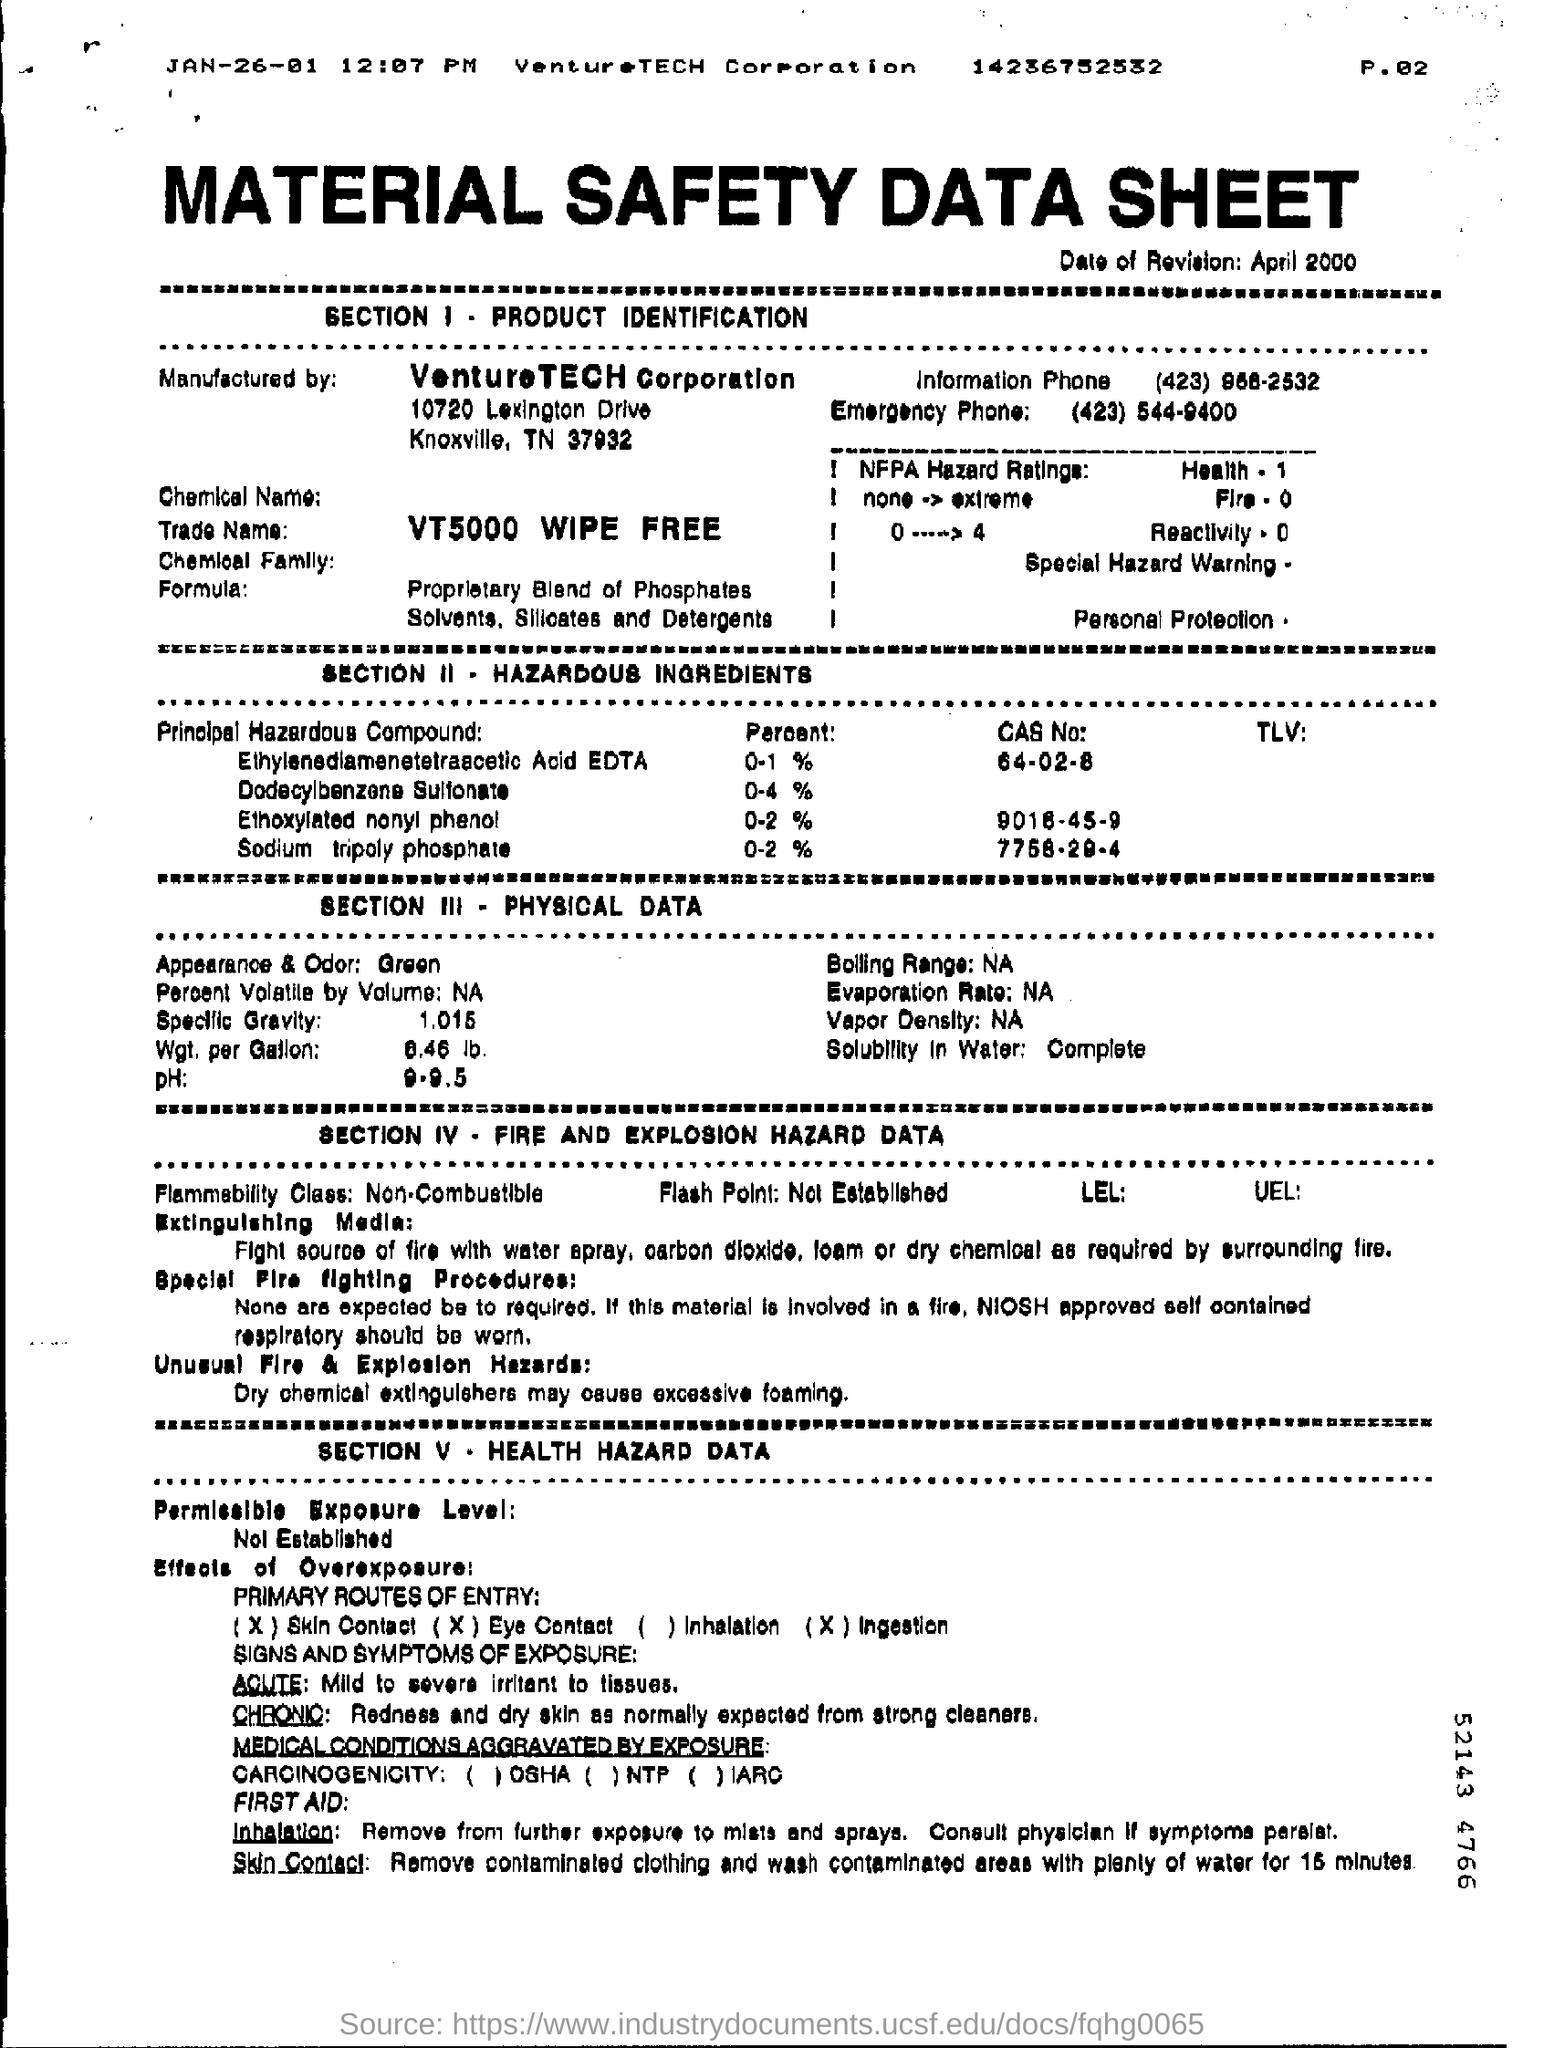What is the Date of Revision?
Give a very brief answer. April 2000. Who is the manufacturer?
Offer a very short reply. VENTURETECH CORPORATION. What does SECTION II deal with?
Offer a very short reply. HAZARDOUS INGREDIENTS. What is the percent of Ethoxylated nonyl phenol?
Provide a succinct answer. 0-2 %. What is the specific gravity?
Keep it short and to the point. 1.015. 